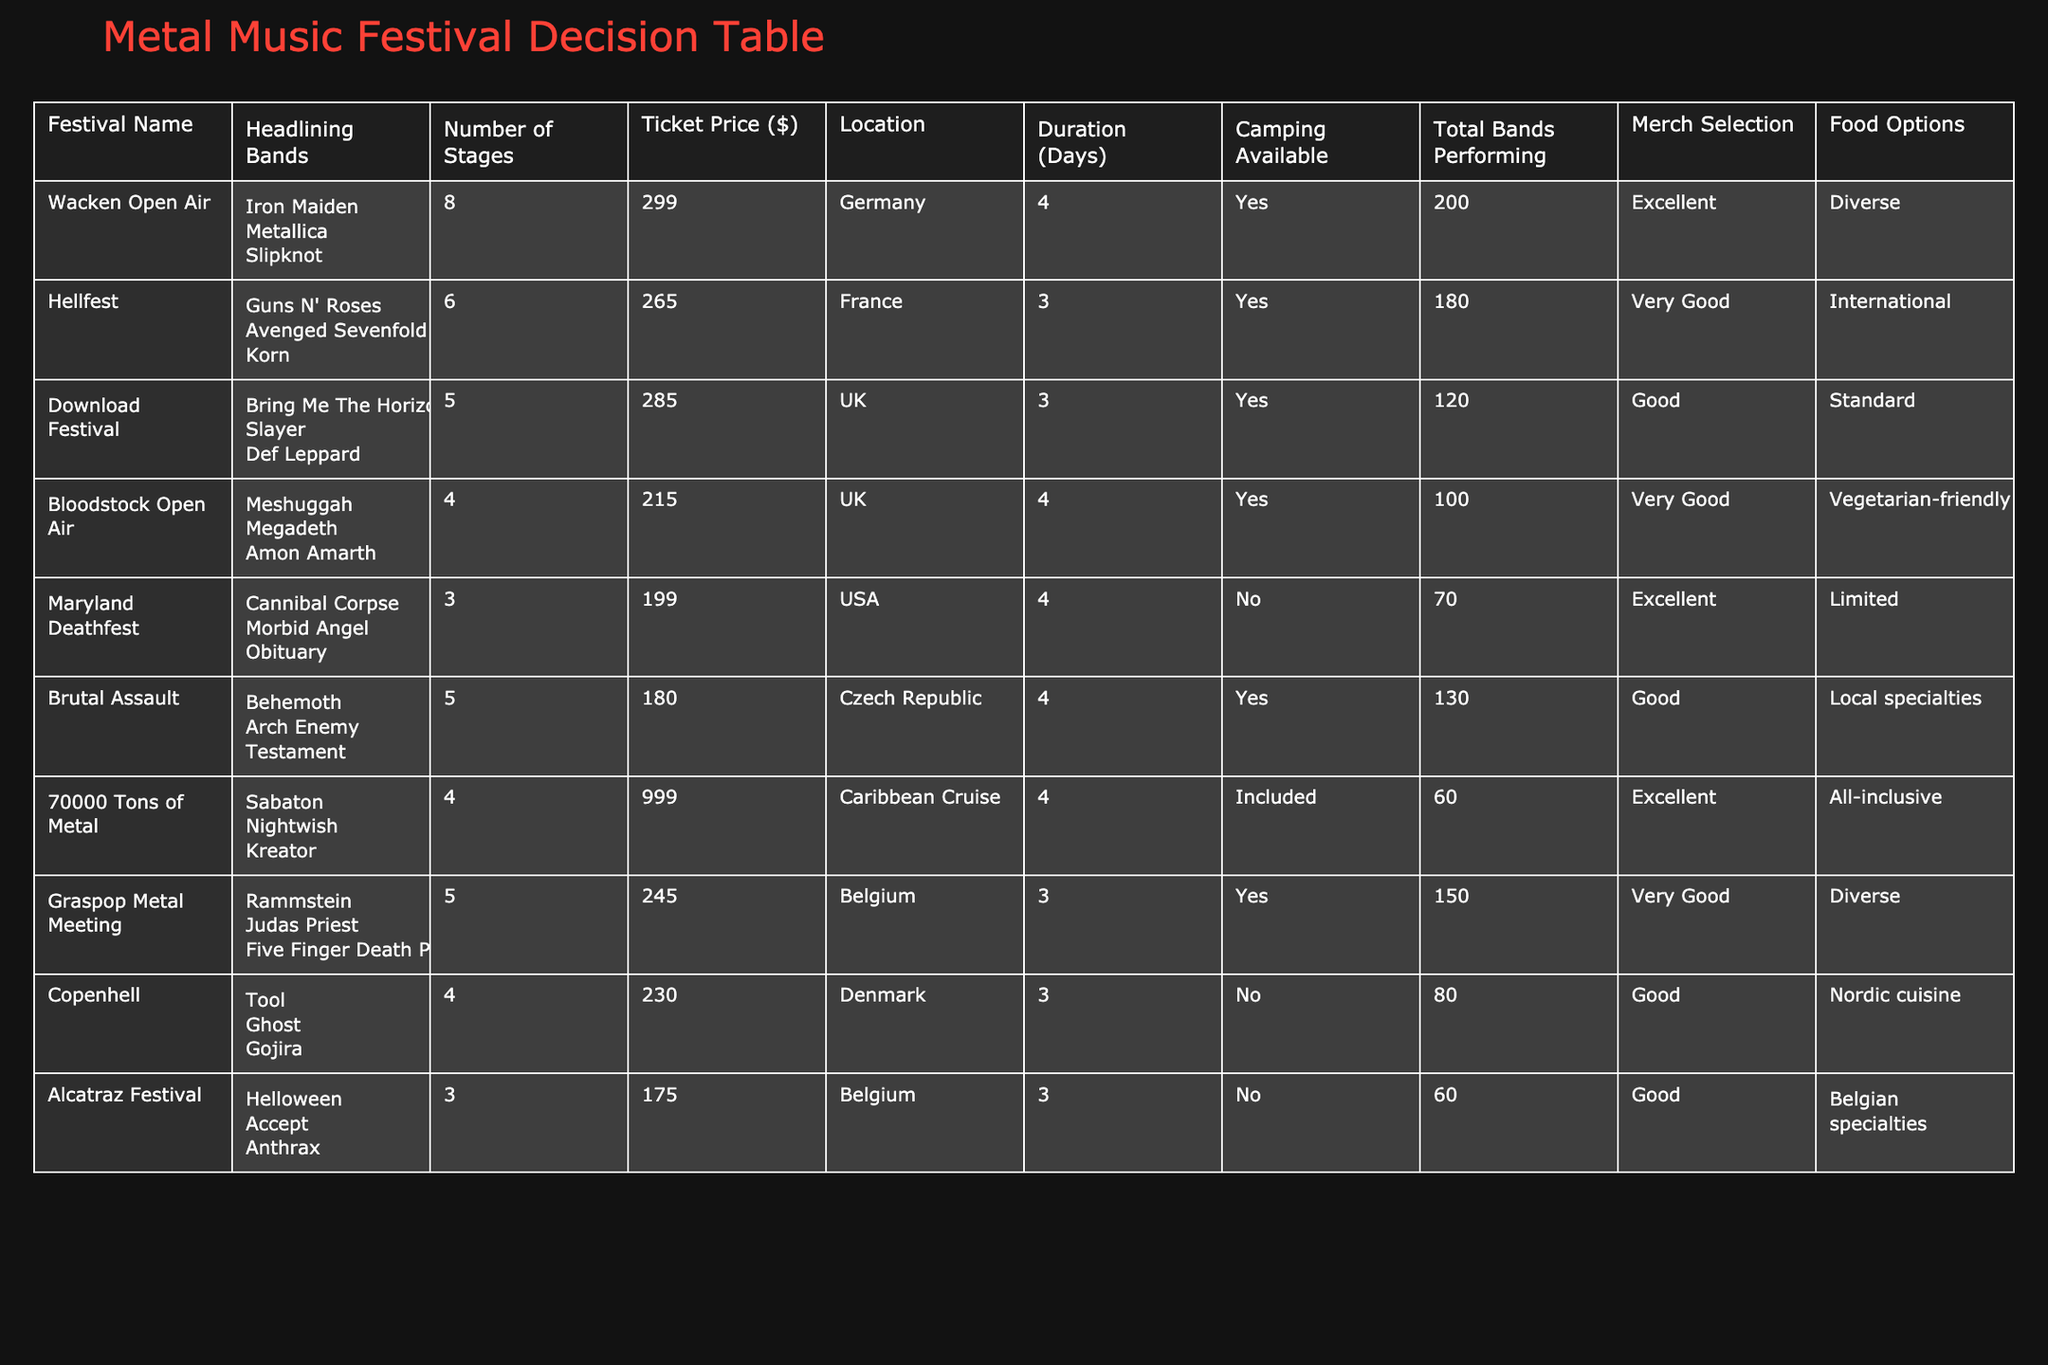What is the ticket price for Wacken Open Air? The ticket price for Wacken Open Air is listed directly in the table as 299.
Answer: 299 How many total bands are performing at Hellfest? The table states that Hellfest has 180 total bands performing.
Answer: 180 Which festival has the highest ticket price, and what is that price? Looking through the ticket prices, 70000 Tons of Metal has the highest ticket price of 999.
Answer: 70000 Tons of Metal, 999 Is there camping available at the Maryland Deathfest? The table records that there is no camping available at the Maryland Deathfest.
Answer: No How many bands are performing at Bloodstock Open Air compared to Download Festival? Bloodstock Open Air features 100 bands while Download Festival has 120. Thus, Download Festival has 20 more bands performing than Bloodstock Open Air.
Answer: Download Festival has 20 more bands Which festival offers an all-inclusive food option, and what is the location? The table shows that 70000 Tons of Metal offers all-inclusive food options, located on a Caribbean Cruise.
Answer: 70000 Tons of Metal, Caribbean Cruise What is the average ticket price for festivals located in Belgium? The ticket prices for the festivals in Belgium are 245 (Graspop Metal Meeting) and 175 (Alcatraz Festival). Adding these gives 420, and dividing by 2 provides an average ticket price of 210.
Answer: 210 How many festivals provide a diverse food option? Reviewing the food options provided in the table, three festivals specify that food options are diverse: Wacken Open Air, Graspop Metal Meeting, and Hellfest.
Answer: 3 Which festival has the lowest number of stages and what is that number? The festival with the lowest number of stages is Maryland Deathfest with only 3 stages.
Answer: 3 